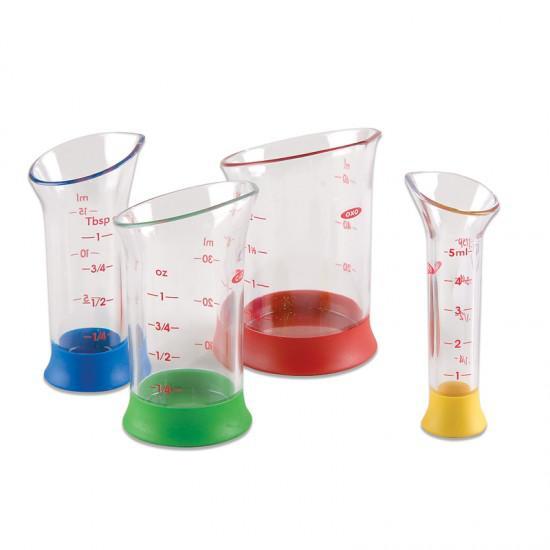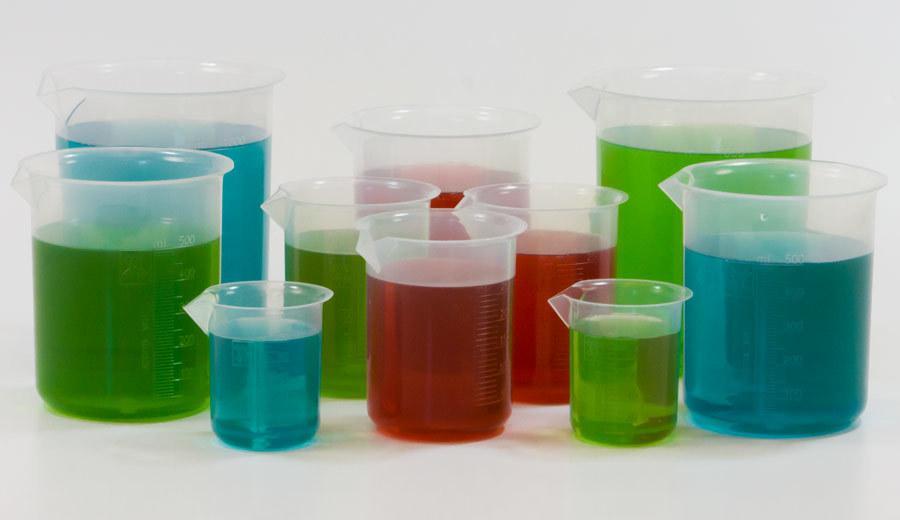The first image is the image on the left, the second image is the image on the right. Given the left and right images, does the statement "At least one of the containers in one of the images is empty." hold true? Answer yes or no. No. The first image is the image on the left, the second image is the image on the right. Given the left and right images, does the statement "The containers in the left image are empty." hold true? Answer yes or no. Yes. 